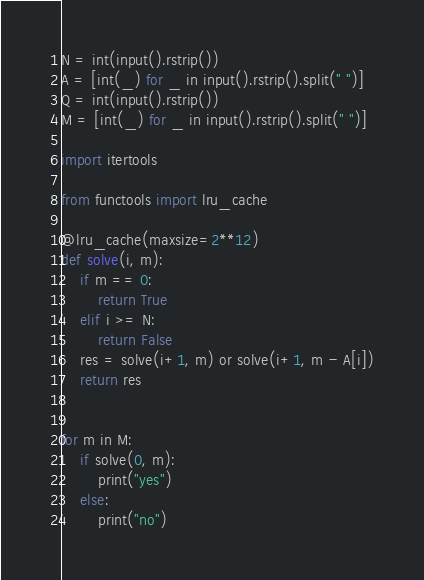Convert code to text. <code><loc_0><loc_0><loc_500><loc_500><_Python_>N = int(input().rstrip())
A = [int(_) for _ in input().rstrip().split(" ")]
Q = int(input().rstrip())
M = [int(_) for _ in input().rstrip().split(" ")]

import itertools

from functools import lru_cache

@lru_cache(maxsize=2**12)
def solve(i, m):
    if m == 0:
        return True
    elif i >= N:
        return False
    res = solve(i+1, m) or solve(i+1, m - A[i])
    return res
        
        
for m in M:
    if solve(0, m):
        print("yes")
    else:
        print("no")
</code> 